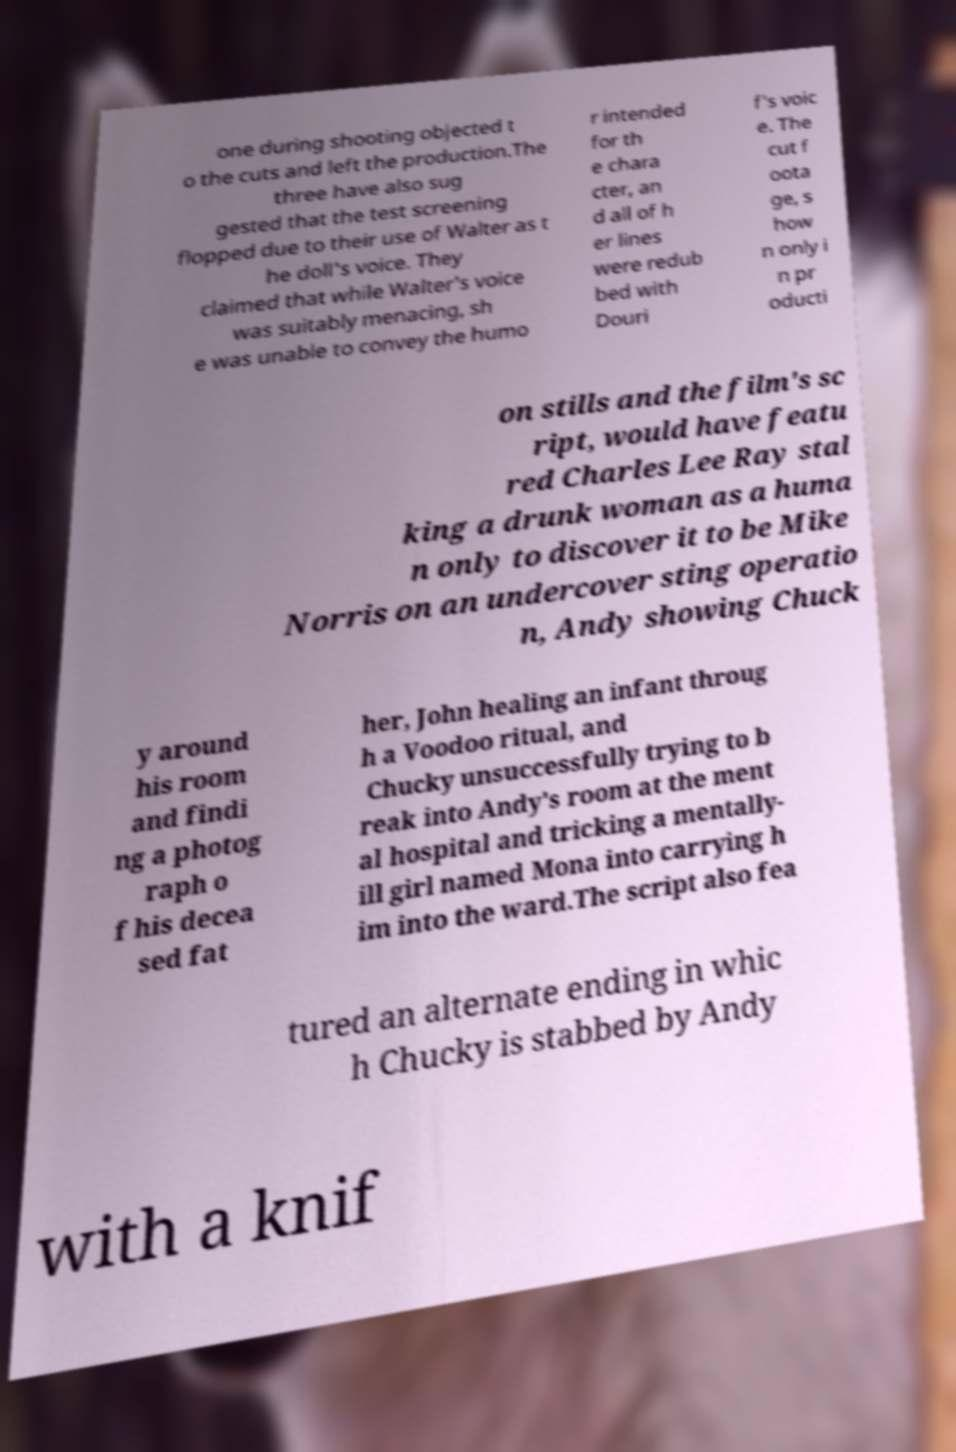There's text embedded in this image that I need extracted. Can you transcribe it verbatim? one during shooting objected t o the cuts and left the production.The three have also sug gested that the test screening flopped due to their use of Walter as t he doll's voice. They claimed that while Walter's voice was suitably menacing, sh e was unable to convey the humo r intended for th e chara cter, an d all of h er lines were redub bed with Douri f's voic e. The cut f oota ge, s how n only i n pr oducti on stills and the film's sc ript, would have featu red Charles Lee Ray stal king a drunk woman as a huma n only to discover it to be Mike Norris on an undercover sting operatio n, Andy showing Chuck y around his room and findi ng a photog raph o f his decea sed fat her, John healing an infant throug h a Voodoo ritual, and Chucky unsuccessfully trying to b reak into Andy's room at the ment al hospital and tricking a mentally- ill girl named Mona into carrying h im into the ward.The script also fea tured an alternate ending in whic h Chucky is stabbed by Andy with a knif 